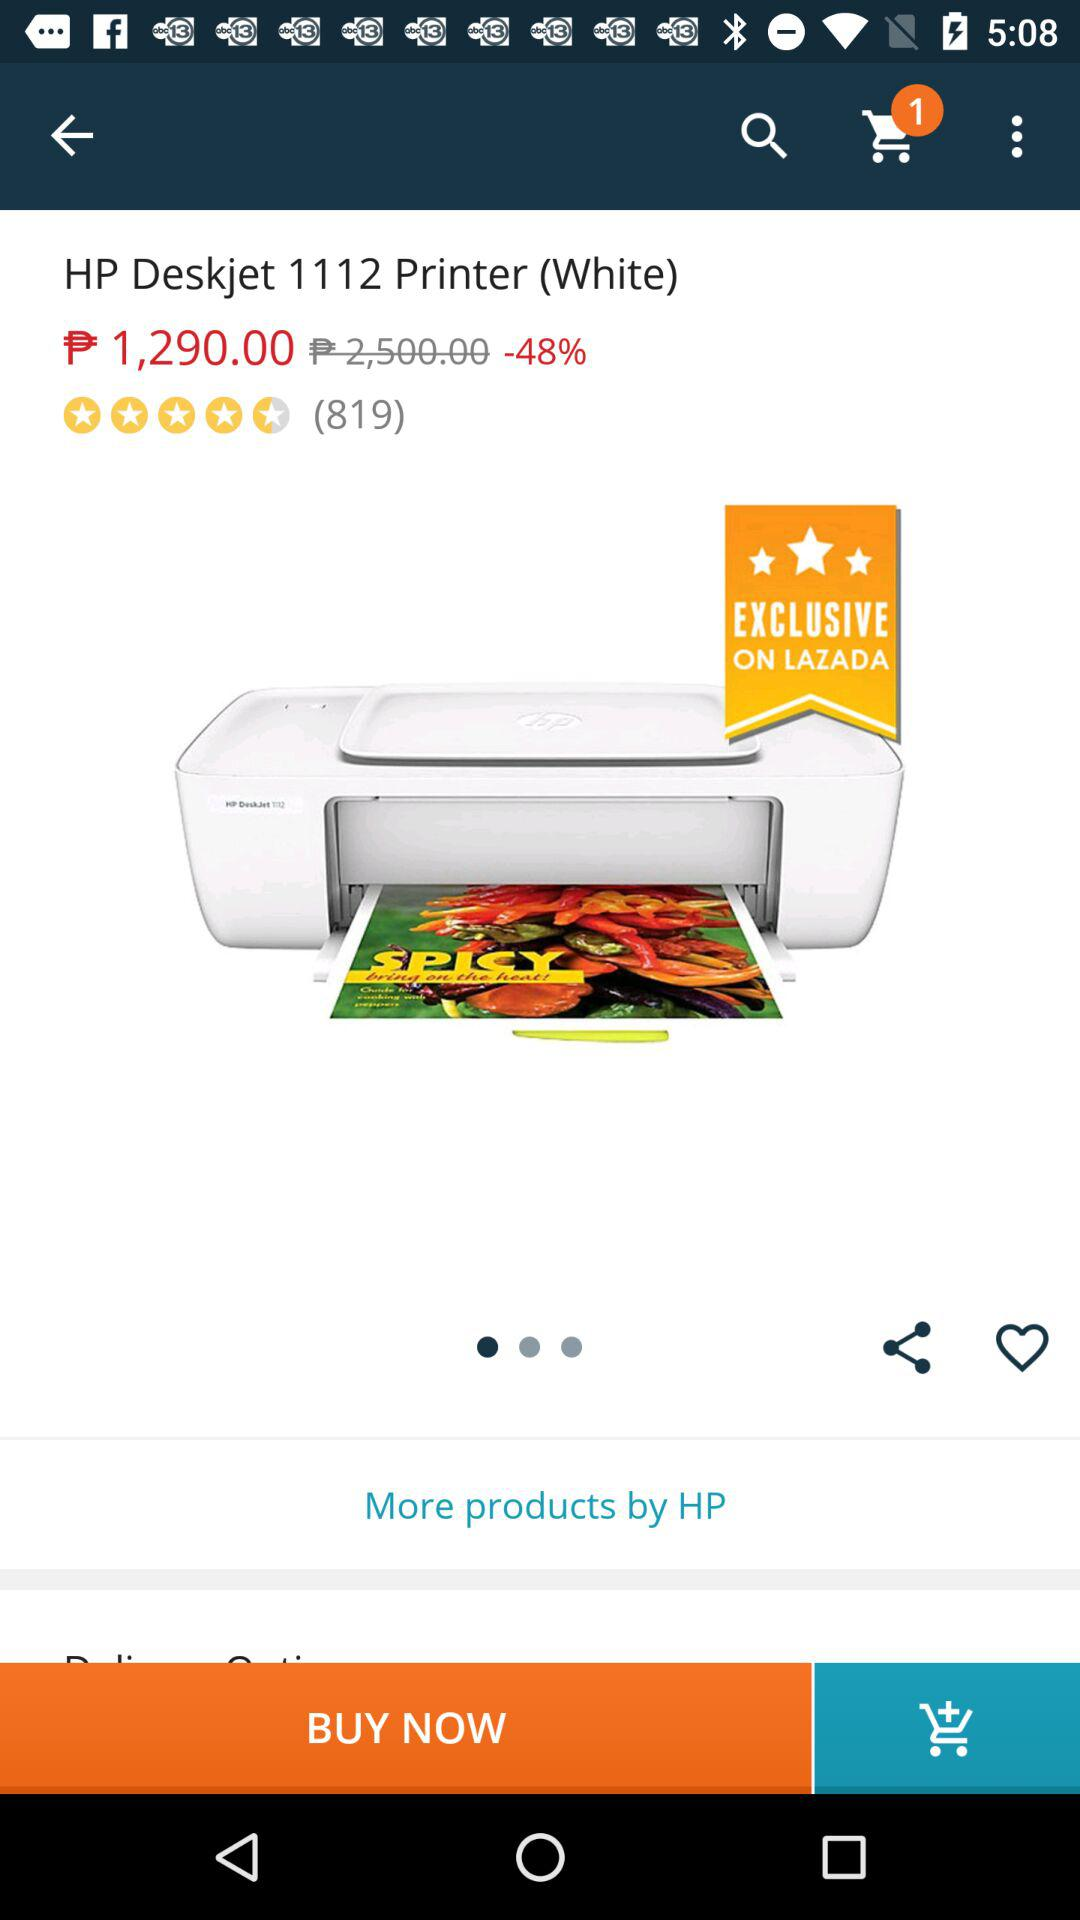How much is the original price of the product?
Answer the question using a single word or phrase. $2,500.00 